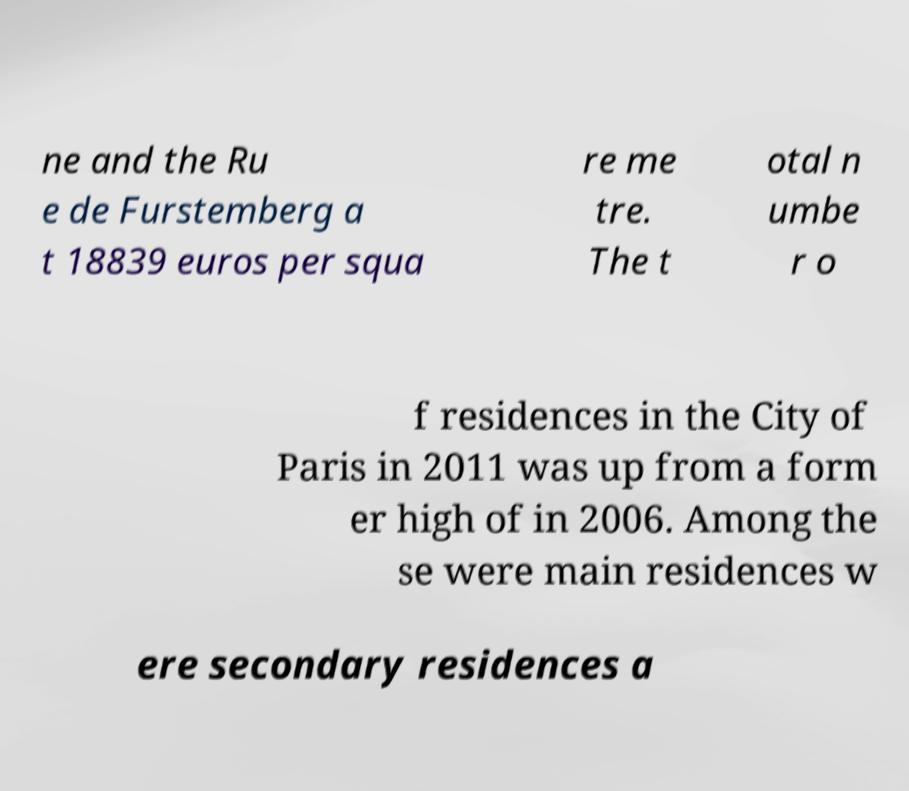Can you read and provide the text displayed in the image?This photo seems to have some interesting text. Can you extract and type it out for me? ne and the Ru e de Furstemberg a t 18839 euros per squa re me tre. The t otal n umbe r o f residences in the City of Paris in 2011 was up from a form er high of in 2006. Among the se were main residences w ere secondary residences a 